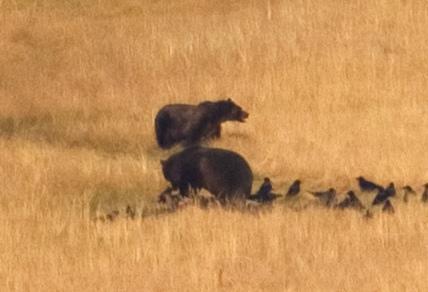How many bears are there?
Give a very brief answer. 2. 